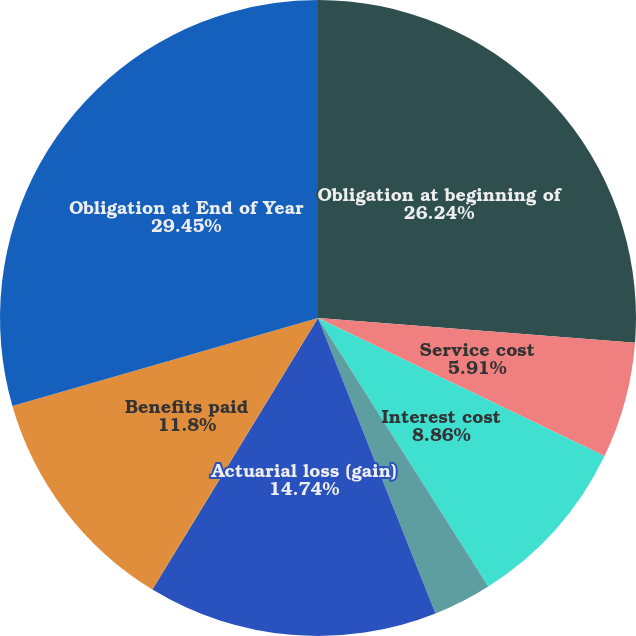Convert chart. <chart><loc_0><loc_0><loc_500><loc_500><pie_chart><fcel>Obligation at beginning of<fcel>Service cost<fcel>Interest cost<fcel>Amendments<fcel>Actuarial loss (gain)<fcel>Settlements<fcel>Benefits paid<fcel>Obligation at End of Year<nl><fcel>26.24%<fcel>5.91%<fcel>8.86%<fcel>2.97%<fcel>14.74%<fcel>0.03%<fcel>11.8%<fcel>29.46%<nl></chart> 